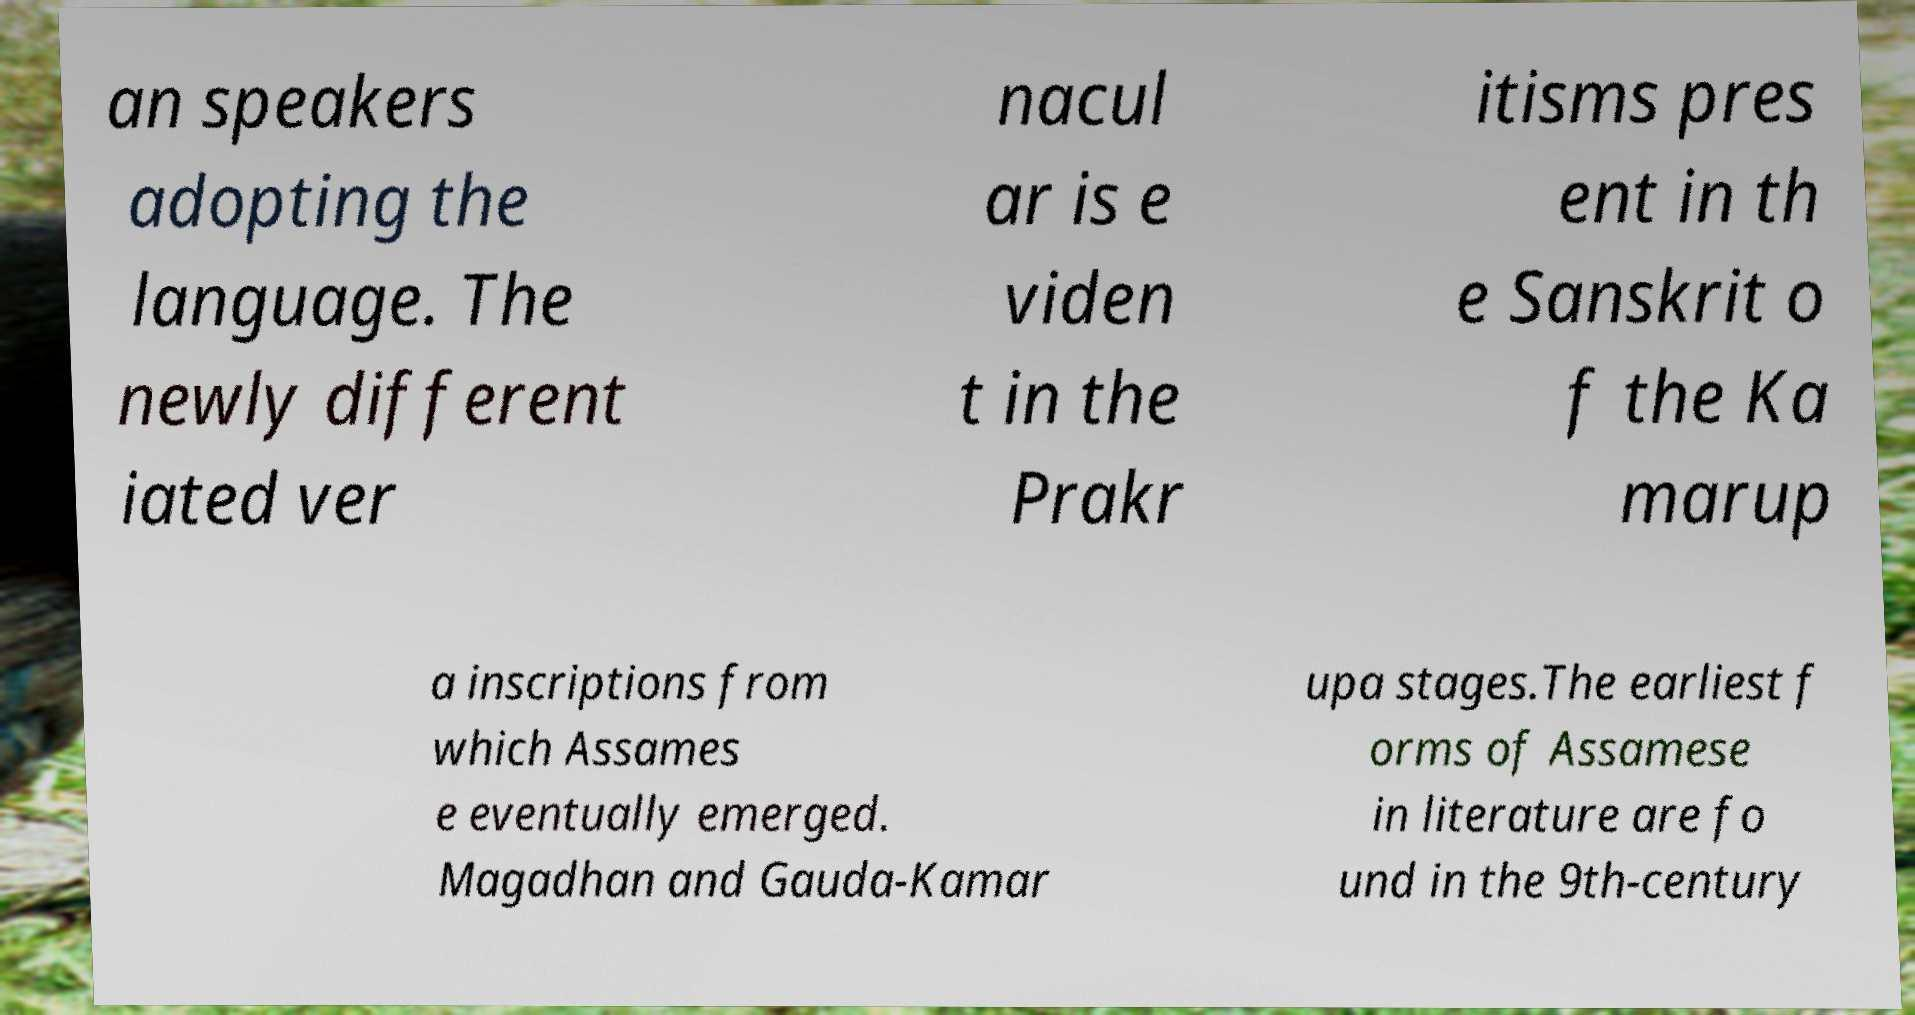There's text embedded in this image that I need extracted. Can you transcribe it verbatim? an speakers adopting the language. The newly different iated ver nacul ar is e viden t in the Prakr itisms pres ent in th e Sanskrit o f the Ka marup a inscriptions from which Assames e eventually emerged. Magadhan and Gauda-Kamar upa stages.The earliest f orms of Assamese in literature are fo und in the 9th-century 